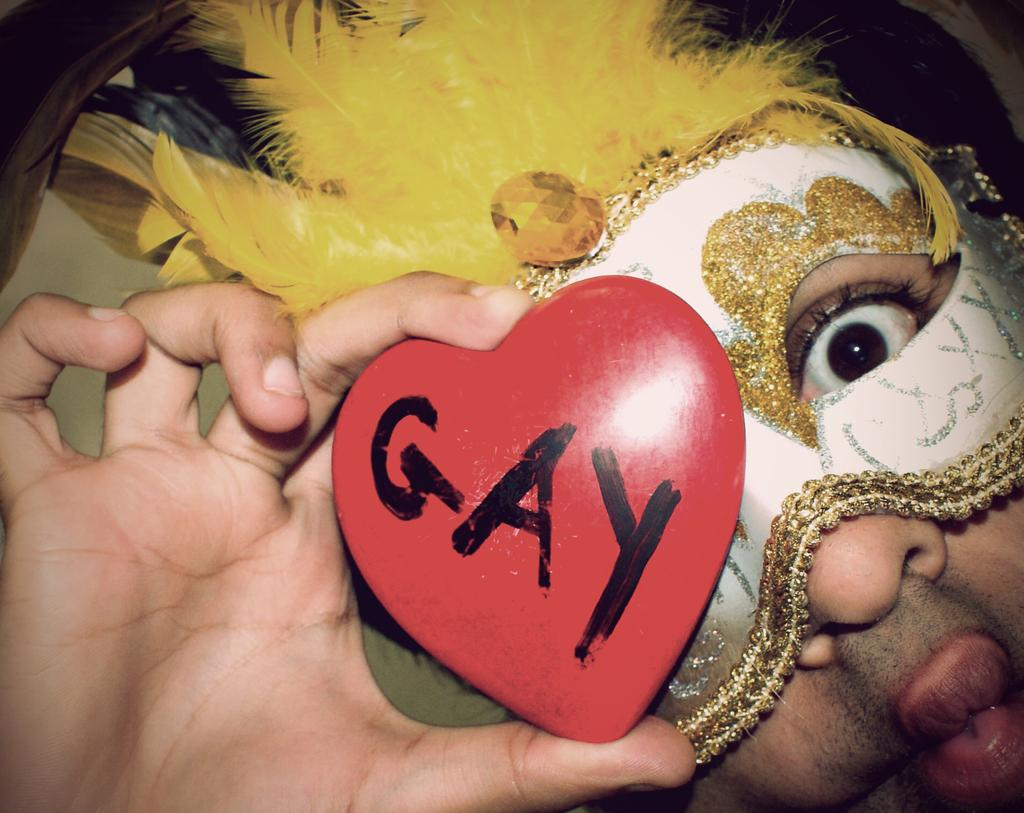Who is present in the image? There is a man in the image. What is the man holding in the image? The man is holding a heart-shaped object. Can you describe the heart-shaped object? The heart-shaped object has text on it. What is the man wearing in the image? The man is wearing a face mask. What is on the man's head in the image? There are feathers on the man's head. What type of magic is the man performing in the image? There is no indication of magic or any magical actions in the image. 